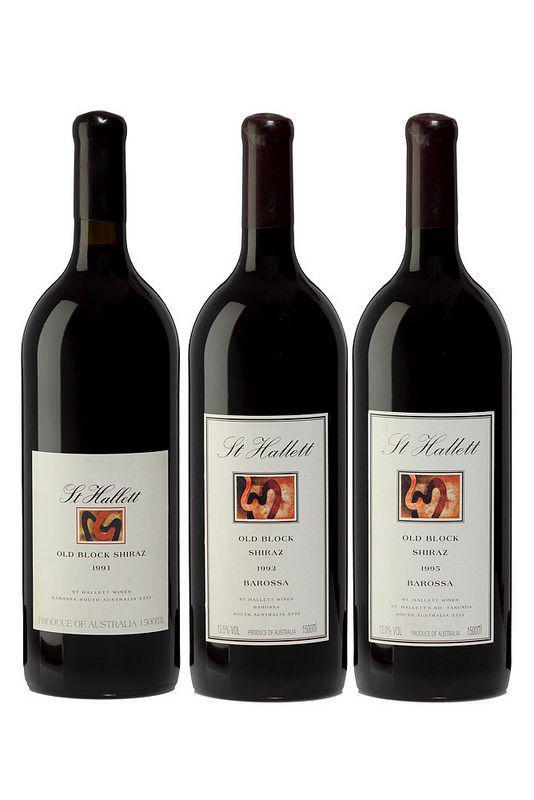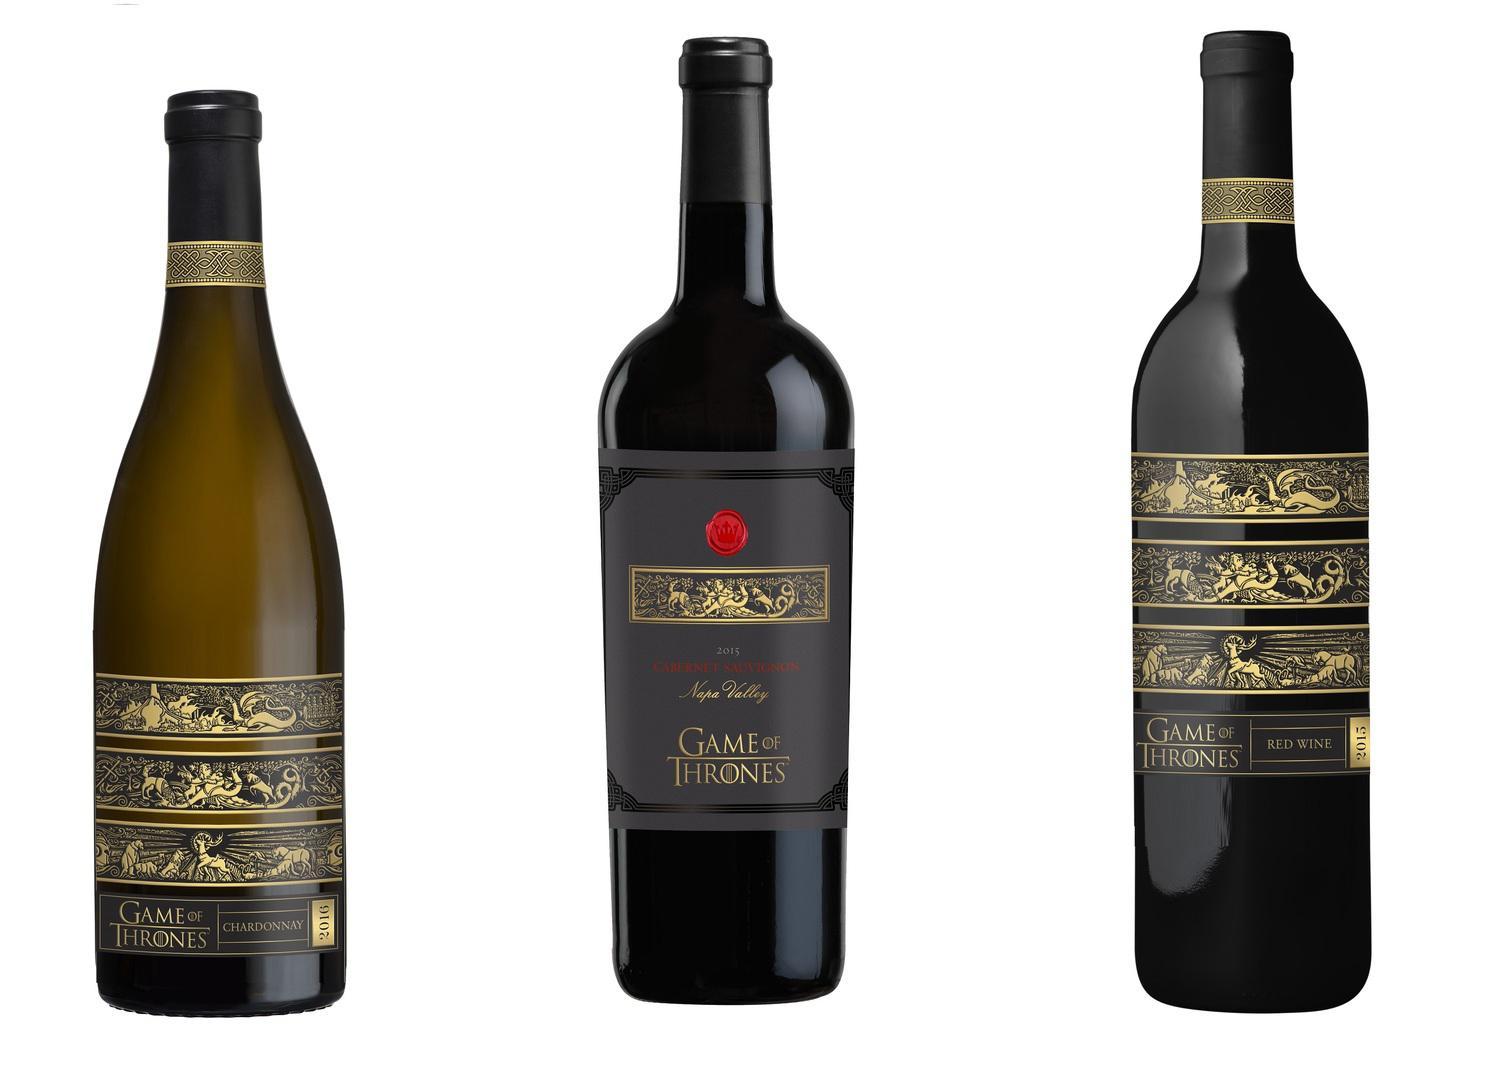The first image is the image on the left, the second image is the image on the right. Given the left and right images, does the statement "There are three wine bottles against a plain white background in each image." hold true? Answer yes or no. Yes. The first image is the image on the left, the second image is the image on the right. Given the left and right images, does the statement "The three bottles in each image all different, but one set of three all have the same label, while one set has different labels." hold true? Answer yes or no. No. The first image is the image on the left, the second image is the image on the right. Assess this claim about the two images: "Each image shows exactly three wine bottles, and no bottles are overlapping.". Correct or not? Answer yes or no. Yes. 